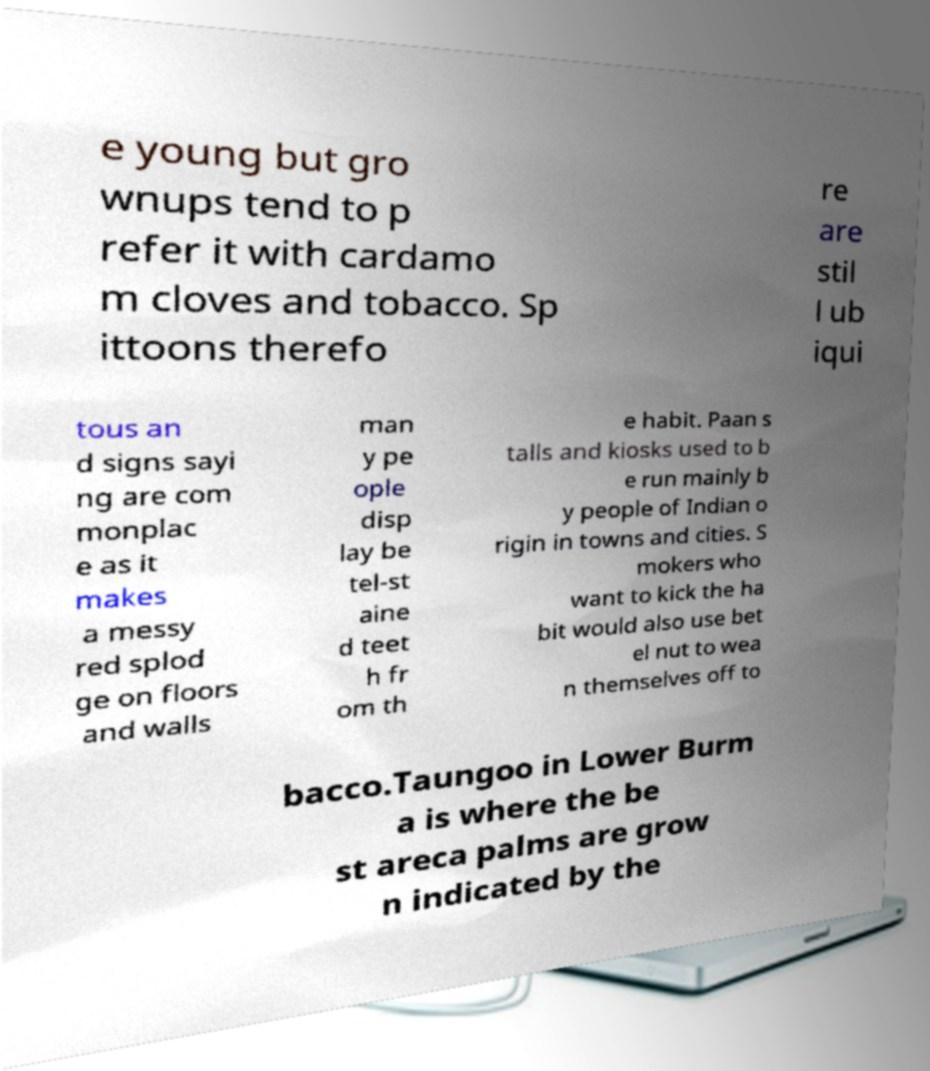Can you read and provide the text displayed in the image?This photo seems to have some interesting text. Can you extract and type it out for me? e young but gro wnups tend to p refer it with cardamo m cloves and tobacco. Sp ittoons therefo re are stil l ub iqui tous an d signs sayi ng are com monplac e as it makes a messy red splod ge on floors and walls man y pe ople disp lay be tel-st aine d teet h fr om th e habit. Paan s talls and kiosks used to b e run mainly b y people of Indian o rigin in towns and cities. S mokers who want to kick the ha bit would also use bet el nut to wea n themselves off to bacco.Taungoo in Lower Burm a is where the be st areca palms are grow n indicated by the 